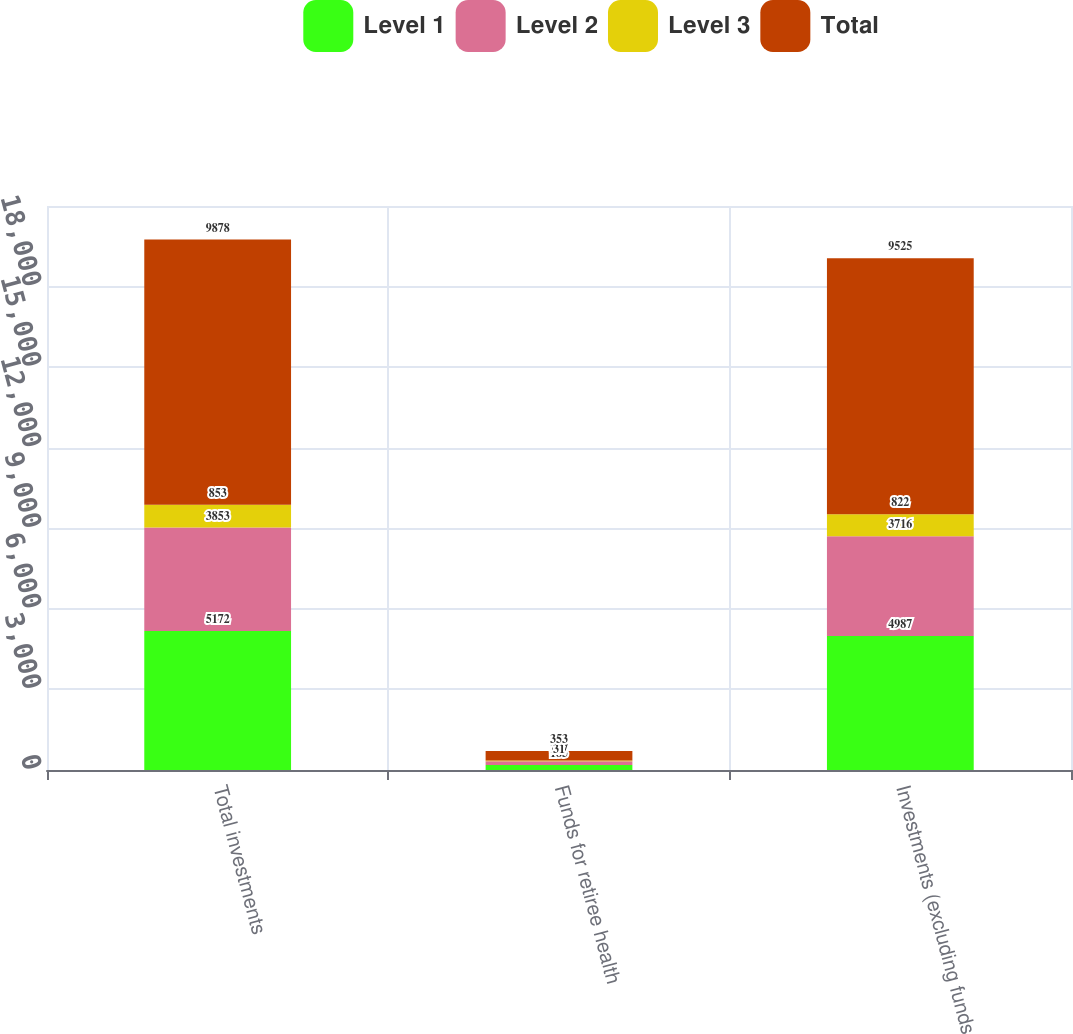<chart> <loc_0><loc_0><loc_500><loc_500><stacked_bar_chart><ecel><fcel>Total investments<fcel>Funds for retiree health<fcel>Investments (excluding funds<nl><fcel>Level 1<fcel>5172<fcel>185<fcel>4987<nl><fcel>Level 2<fcel>3853<fcel>137<fcel>3716<nl><fcel>Level 3<fcel>853<fcel>31<fcel>822<nl><fcel>Total<fcel>9878<fcel>353<fcel>9525<nl></chart> 